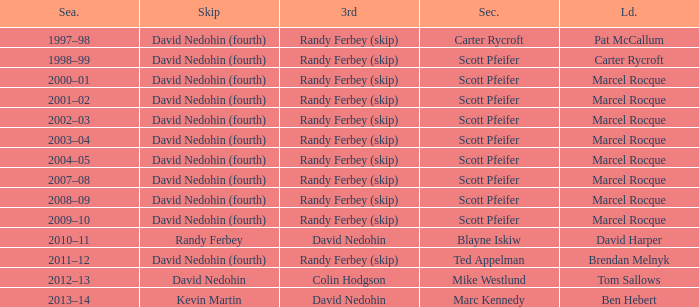Which Lead has a Third of randy ferbey (skip), a Second of scott pfeifer, and a Season of 2009–10? Marcel Rocque. 